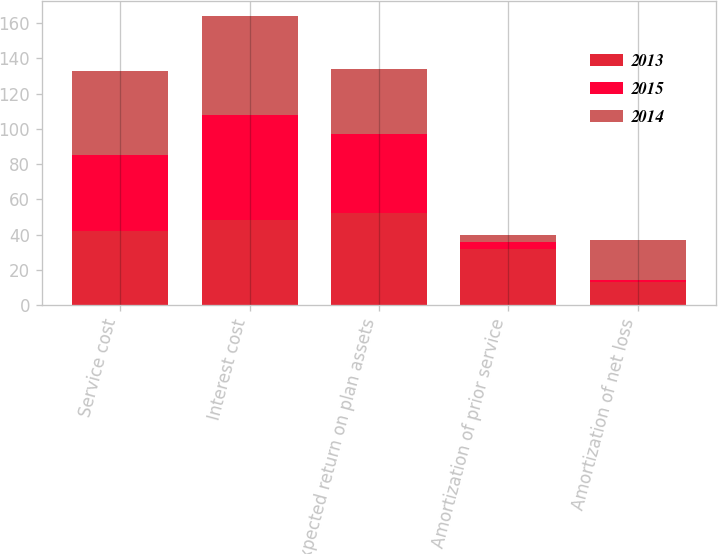<chart> <loc_0><loc_0><loc_500><loc_500><stacked_bar_chart><ecel><fcel>Service cost<fcel>Interest cost<fcel>Expected return on plan assets<fcel>Amortization of prior service<fcel>Amortization of net loss<nl><fcel>2013<fcel>42<fcel>48<fcel>52<fcel>32<fcel>13<nl><fcel>2015<fcel>43<fcel>60<fcel>45<fcel>4<fcel>1<nl><fcel>2014<fcel>48<fcel>56<fcel>37<fcel>4<fcel>23<nl></chart> 